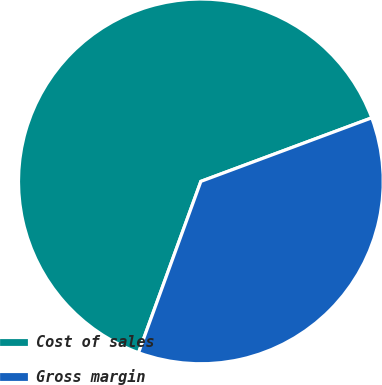Convert chart. <chart><loc_0><loc_0><loc_500><loc_500><pie_chart><fcel>Cost of sales<fcel>Gross margin<nl><fcel>63.78%<fcel>36.22%<nl></chart> 